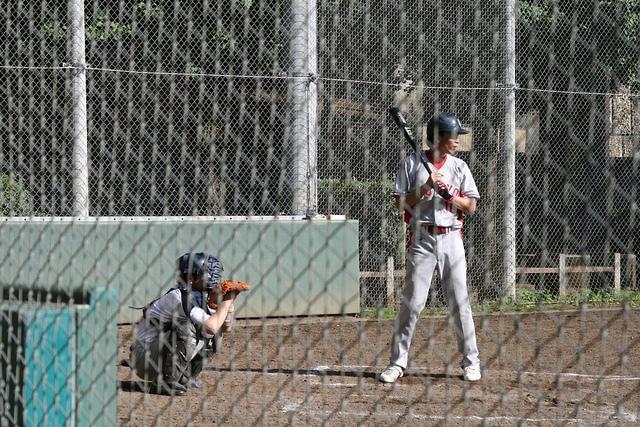How many people are standing?
Give a very brief answer. 1. How many people are there?
Give a very brief answer. 2. How many elephants are here?
Give a very brief answer. 0. 